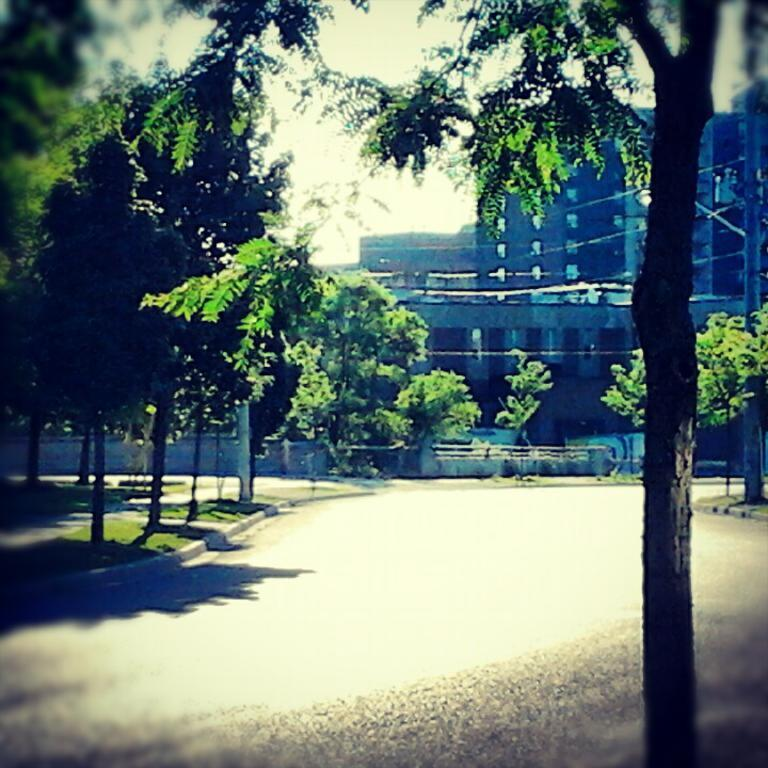What type of vegetation is present in the image? There are many trees in the image. What structure can be seen in the image? There is a pole in the image. What type of pathway is visible in the image? There is a road and a walkway in the image. What can be seen in the background of the image? There are buildings and the sky visible in the background of the image. What type of brass part is visible on the trees in the image? There is no brass part present on the trees in the image; they are simply trees. What type of glass object can be seen on the walkway in the image? There is no glass object present on the walkway in the image. 